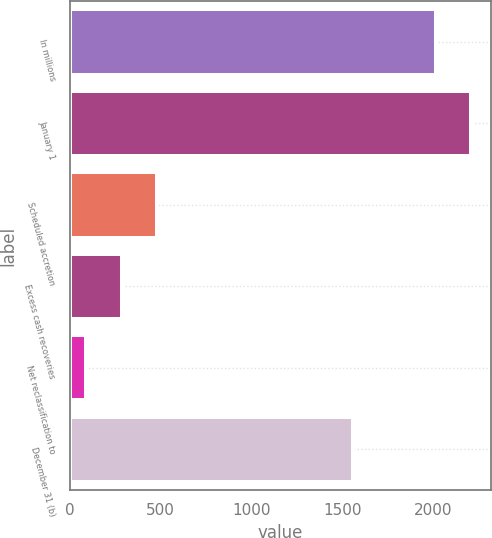Convert chart. <chart><loc_0><loc_0><loc_500><loc_500><bar_chart><fcel>In millions<fcel>January 1<fcel>Scheduled accretion<fcel>Excess cash recoveries<fcel>Net reclassification to<fcel>December 31 (b)<nl><fcel>2014<fcel>2210.5<fcel>483<fcel>286.5<fcel>90<fcel>1558<nl></chart> 